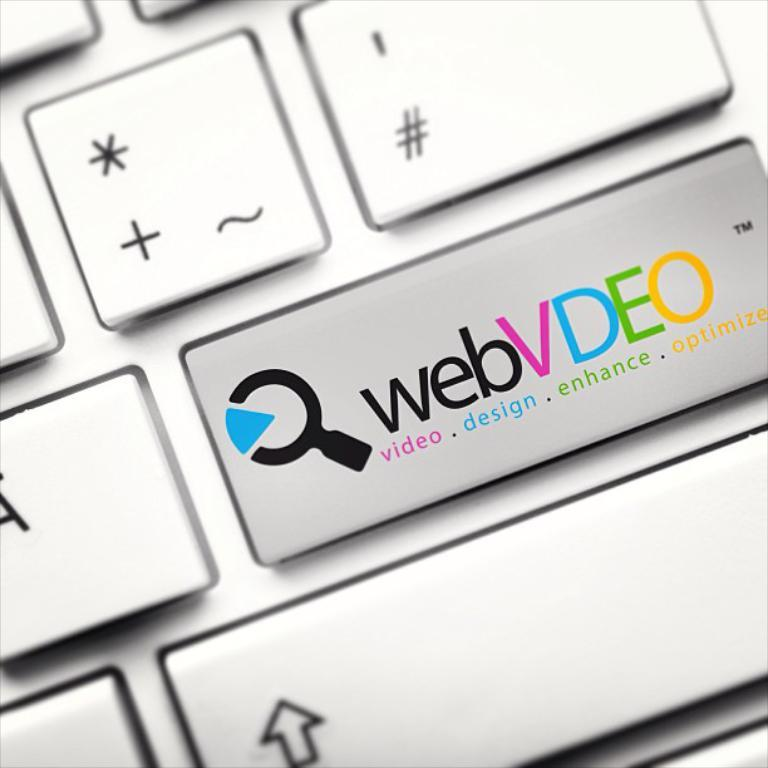<image>
Share a concise interpretation of the image provided. A keyboard button says webVDEO on it and has a picture of a magnifying glass. 